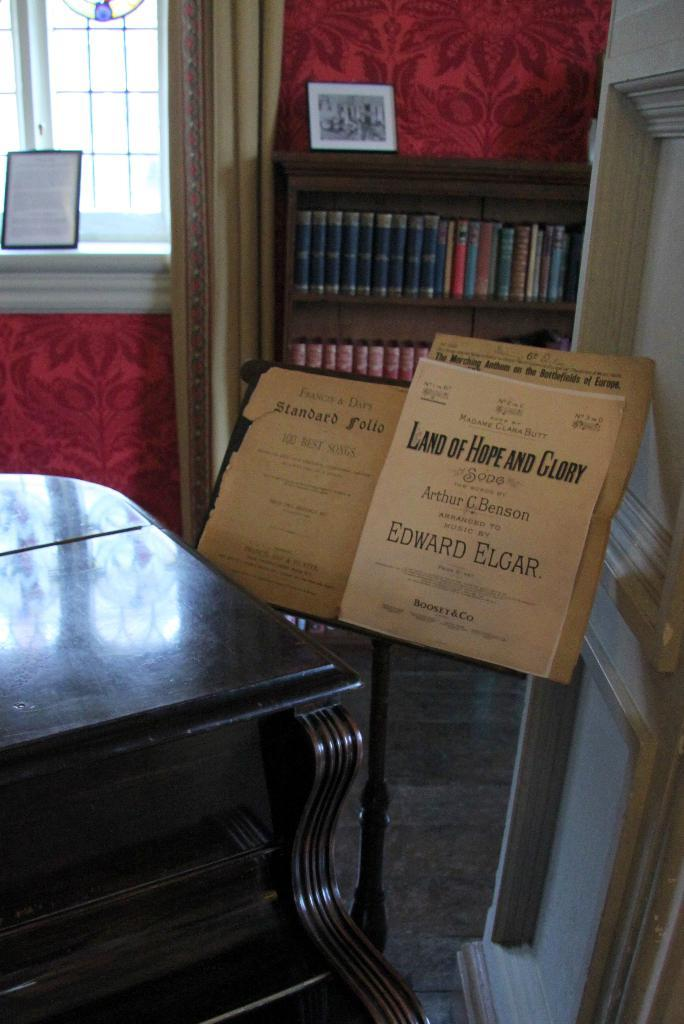<image>
Describe the image concisely. Music on a stand with Land of Hope and Glory written on it 